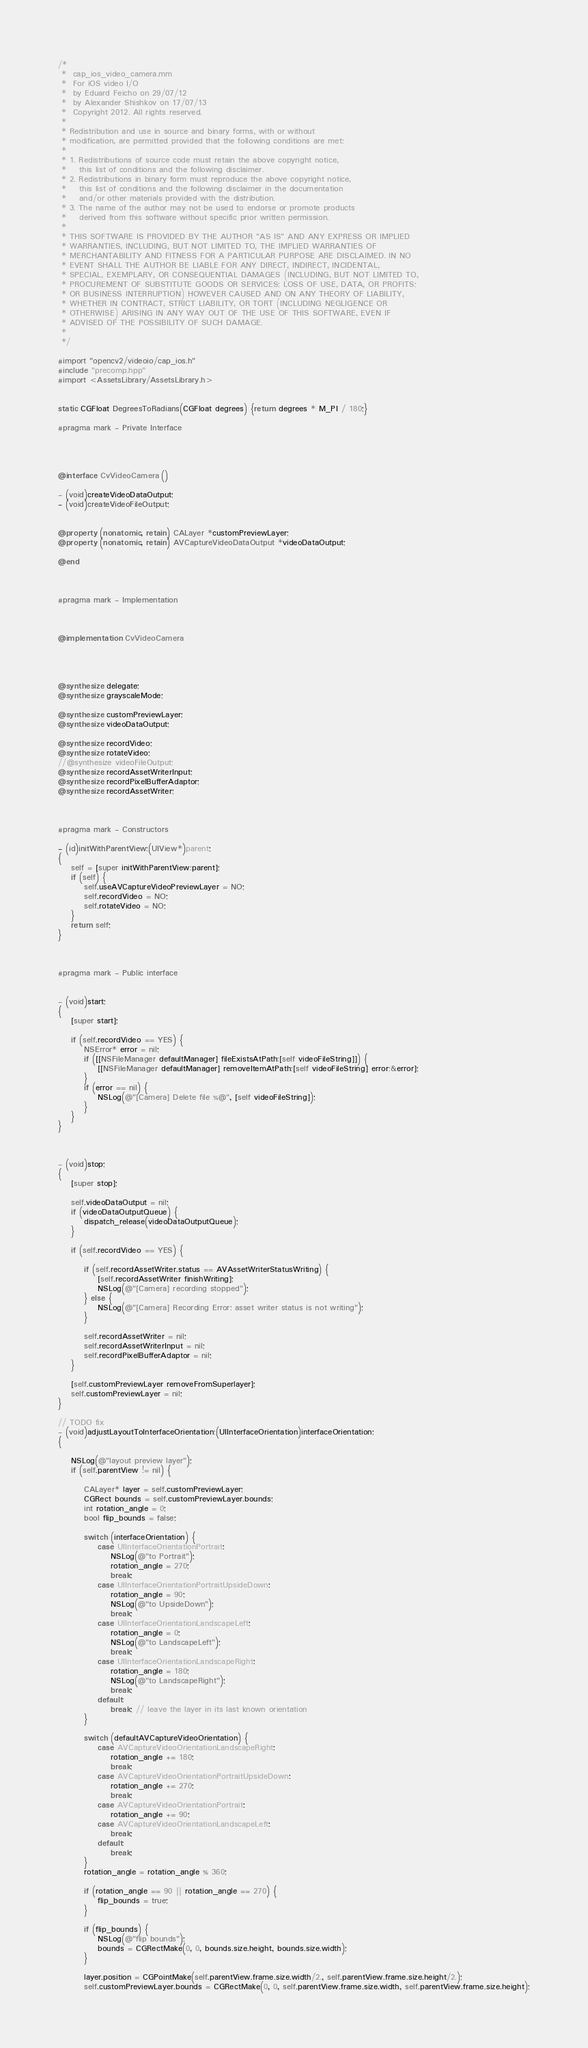<code> <loc_0><loc_0><loc_500><loc_500><_ObjectiveC_>/*
 *  cap_ios_video_camera.mm
 *  For iOS video I/O
 *  by Eduard Feicho on 29/07/12
 *  by Alexander Shishkov on 17/07/13
 *  Copyright 2012. All rights reserved.
 *
 * Redistribution and use in source and binary forms, with or without
 * modification, are permitted provided that the following conditions are met:
 *
 * 1. Redistributions of source code must retain the above copyright notice,
 *    this list of conditions and the following disclaimer.
 * 2. Redistributions in binary form must reproduce the above copyright notice,
 *    this list of conditions and the following disclaimer in the documentation
 *    and/or other materials provided with the distribution.
 * 3. The name of the author may not be used to endorse or promote products
 *    derived from this software without specific prior written permission.
 *
 * THIS SOFTWARE IS PROVIDED BY THE AUTHOR "AS IS" AND ANY EXPRESS OR IMPLIED
 * WARRANTIES, INCLUDING, BUT NOT LIMITED TO, THE IMPLIED WARRANTIES OF
 * MERCHANTABILITY AND FITNESS FOR A PARTICULAR PURPOSE ARE DISCLAIMED. IN NO
 * EVENT SHALL THE AUTHOR BE LIABLE FOR ANY DIRECT, INDIRECT, INCIDENTAL,
 * SPECIAL, EXEMPLARY, OR CONSEQUENTIAL DAMAGES (INCLUDING, BUT NOT LIMITED TO,
 * PROCUREMENT OF SUBSTITUTE GOODS OR SERVICES; LOSS OF USE, DATA, OR PROFITS;
 * OR BUSINESS INTERRUPTION) HOWEVER CAUSED AND ON ANY THEORY OF LIABILITY,
 * WHETHER IN CONTRACT, STRICT LIABILITY, OR TORT (INCLUDING NEGLIGENCE OR
 * OTHERWISE) ARISING IN ANY WAY OUT OF THE USE OF THIS SOFTWARE, EVEN IF
 * ADVISED OF THE POSSIBILITY OF SUCH DAMAGE.
 *
 */

#import "opencv2/videoio/cap_ios.h"
#include "precomp.hpp"
#import <AssetsLibrary/AssetsLibrary.h>


static CGFloat DegreesToRadians(CGFloat degrees) {return degrees * M_PI / 180;}

#pragma mark - Private Interface




@interface CvVideoCamera ()

- (void)createVideoDataOutput;
- (void)createVideoFileOutput;


@property (nonatomic, retain) CALayer *customPreviewLayer;
@property (nonatomic, retain) AVCaptureVideoDataOutput *videoDataOutput;

@end



#pragma mark - Implementation



@implementation CvVideoCamera




@synthesize delegate;
@synthesize grayscaleMode;

@synthesize customPreviewLayer;
@synthesize videoDataOutput;

@synthesize recordVideo;
@synthesize rotateVideo;
//@synthesize videoFileOutput;
@synthesize recordAssetWriterInput;
@synthesize recordPixelBufferAdaptor;
@synthesize recordAssetWriter;



#pragma mark - Constructors

- (id)initWithParentView:(UIView*)parent;
{
    self = [super initWithParentView:parent];
    if (self) {
        self.useAVCaptureVideoPreviewLayer = NO;
        self.recordVideo = NO;
        self.rotateVideo = NO;
    }
    return self;
}



#pragma mark - Public interface


- (void)start;
{
    [super start];

    if (self.recordVideo == YES) {
        NSError* error = nil;
        if ([[NSFileManager defaultManager] fileExistsAtPath:[self videoFileString]]) {
            [[NSFileManager defaultManager] removeItemAtPath:[self videoFileString] error:&error];
        }
        if (error == nil) {
            NSLog(@"[Camera] Delete file %@", [self videoFileString]);
        }
    }
}



- (void)stop;
{
    [super stop];

    self.videoDataOutput = nil;
    if (videoDataOutputQueue) {
        dispatch_release(videoDataOutputQueue);
    }

    if (self.recordVideo == YES) {

        if (self.recordAssetWriter.status == AVAssetWriterStatusWriting) {
            [self.recordAssetWriter finishWriting];
            NSLog(@"[Camera] recording stopped");
        } else {
            NSLog(@"[Camera] Recording Error: asset writer status is not writing");
        }

        self.recordAssetWriter = nil;
        self.recordAssetWriterInput = nil;
        self.recordPixelBufferAdaptor = nil;
    }

    [self.customPreviewLayer removeFromSuperlayer];
    self.customPreviewLayer = nil;
}

// TODO fix
- (void)adjustLayoutToInterfaceOrientation:(UIInterfaceOrientation)interfaceOrientation;
{

    NSLog(@"layout preview layer");
    if (self.parentView != nil) {

        CALayer* layer = self.customPreviewLayer;
        CGRect bounds = self.customPreviewLayer.bounds;
        int rotation_angle = 0;
        bool flip_bounds = false;

        switch (interfaceOrientation) {
            case UIInterfaceOrientationPortrait:
                NSLog(@"to Portrait");
                rotation_angle = 270;
                break;
            case UIInterfaceOrientationPortraitUpsideDown:
                rotation_angle = 90;
                NSLog(@"to UpsideDown");
                break;
            case UIInterfaceOrientationLandscapeLeft:
                rotation_angle = 0;
                NSLog(@"to LandscapeLeft");
                break;
            case UIInterfaceOrientationLandscapeRight:
                rotation_angle = 180;
                NSLog(@"to LandscapeRight");
                break;
            default:
                break; // leave the layer in its last known orientation
        }

        switch (defaultAVCaptureVideoOrientation) {
            case AVCaptureVideoOrientationLandscapeRight:
                rotation_angle += 180;
                break;
            case AVCaptureVideoOrientationPortraitUpsideDown:
                rotation_angle += 270;
                break;
            case AVCaptureVideoOrientationPortrait:
                rotation_angle += 90;
            case AVCaptureVideoOrientationLandscapeLeft:
                break;
            default:
                break;
        }
        rotation_angle = rotation_angle % 360;

        if (rotation_angle == 90 || rotation_angle == 270) {
            flip_bounds = true;
        }

        if (flip_bounds) {
            NSLog(@"flip bounds");
            bounds = CGRectMake(0, 0, bounds.size.height, bounds.size.width);
        }

        layer.position = CGPointMake(self.parentView.frame.size.width/2., self.parentView.frame.size.height/2.);
        self.customPreviewLayer.bounds = CGRectMake(0, 0, self.parentView.frame.size.width, self.parentView.frame.size.height);
</code> 